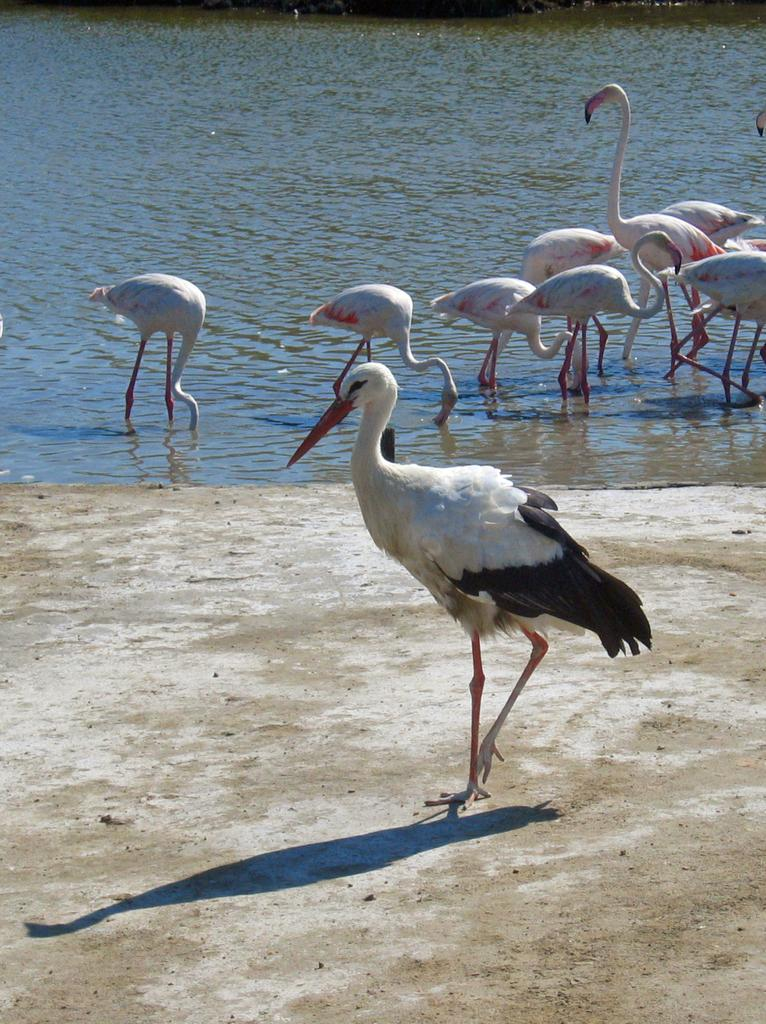What is the bird in the foreground of the image doing? The bird in the foreground of the image is walking on the ground. What can be observed about the bird's shadow in the image? The bird's shadow is visible in the image. Can you describe the birds in the background of the image? The birds in the background of the image are partially in the water. What type of stone is the bird using to spy on the other birds in the image? There is no stone or spying activity present in the image; it features a bird walking on the ground and other birds in the background. 